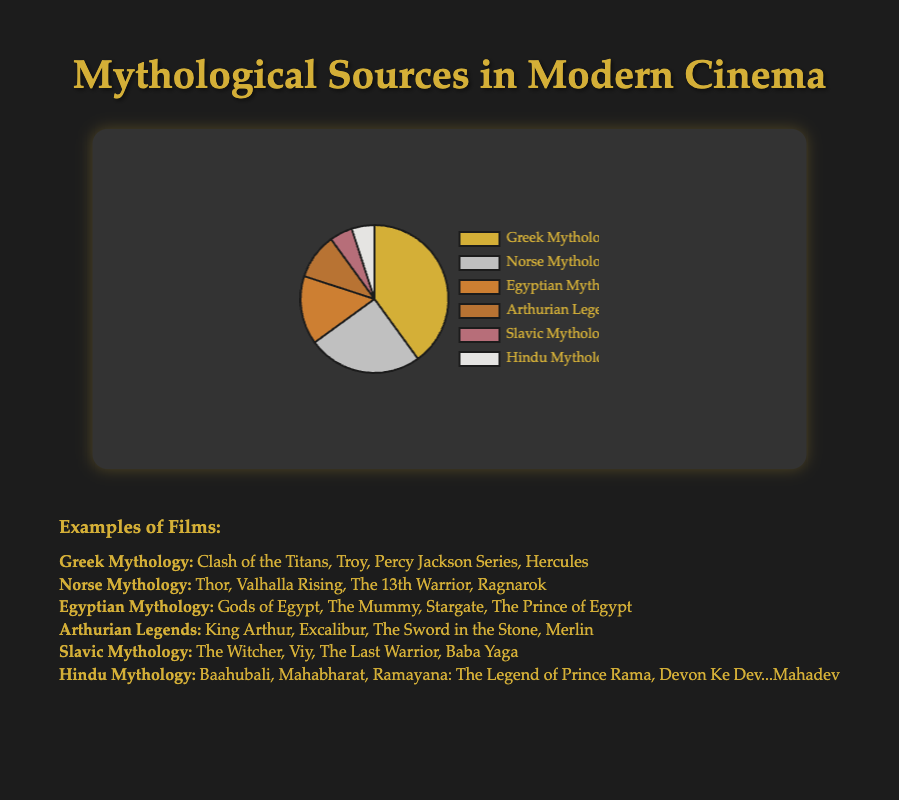What are the percentages of Greek Mythology and Norse Mythology combined? Greek Mythology constitutes 40% and Norse Mythology constitutes 25%. By adding these two percentages together, 40 + 25 = 65.
Answer: 65% Which mythology has the least representation in modern film adaptations? From the pie chart, Slavic Mythology and Hindu Mythology both have the smallest segment, each at 5%.
Answer: Slavic Mythology and Hindu Mythology How much larger is the segment for Egyptian Mythology compared to the Arthurian Legends? The percentage for Egyptian Mythology is 15%, while the percentage for Arthurian Legends is 10%. The difference is 15 - 10 = 5.
Answer: 5% What is the total percentage of adaptations that are not based on Greek or Norse mythology? To find this, add the percentages of the other sources: Egyptian (15%) + Arthurian (10%) + Slavic (5%) + Hindu (5%) = 35.
Answer: 35% What color segment represents the Greek Mythology category? In the pie chart, the Greek Mythology segment is represented by the gold-colored segment.
Answer: Gold Compare the combined percentage of Egyptian and Arthurian Legends to that of Norse Mythology. Which is greater and by how much? Egyptian Mythology is 15% and Arthurian Legends is 10%, so their total is 15 + 10 = 25%. Norse Mythology is also 25%. Therefore, they are equal.
Answer: Equal Which source of myth has more representation: Slavic Mythology or Hindu Mythology? Both Slavic Mythology and Hindu Mythology each represent 5% of the adaptations, making them equal in representation.
Answer: Equal How many more examples are given for Norse Mythology compared to Slavic Mythology? Norse Mythology has 4 examples listed, and Slavic Mythology also has 4 examples, so the difference is 4 - 4 = 0.
Answer: 0 What is the most common source of myths for modern film adaptations? The largest segment in the pie chart is Greek Mythology, which constitutes 40%.
Answer: Greek Mythology 